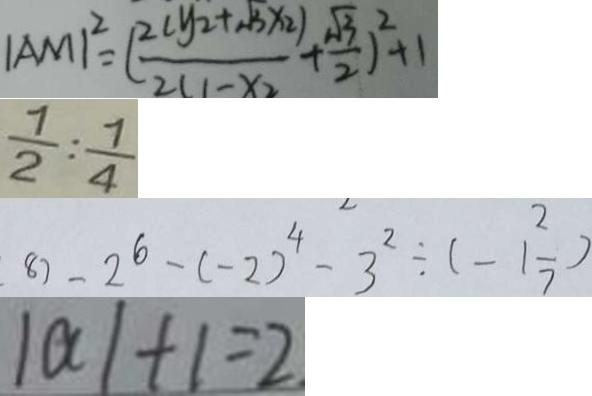<formula> <loc_0><loc_0><loc_500><loc_500>\vert A M \vert ^ { 2 } = ( \frac { 2 ( y _ { 2 } + \sqrt { 3 } x _ { 2 } ) } { 2 ( 1 - x _ { 2 } } + \frac { \sqrt { 3 } } { 2 } ) ^ { 2 } + 1 
 \frac { 7 } { 2 } : \frac { 7 } { 4 } 
 8 ) - 2 ^ { 6 } - ( - 2 ) ^ { 4 } - 3 ^ { 2 } \div ( - 1 \frac { 2 } { 7 } ) 
 \vert a \vert + 1 = 2</formula> 